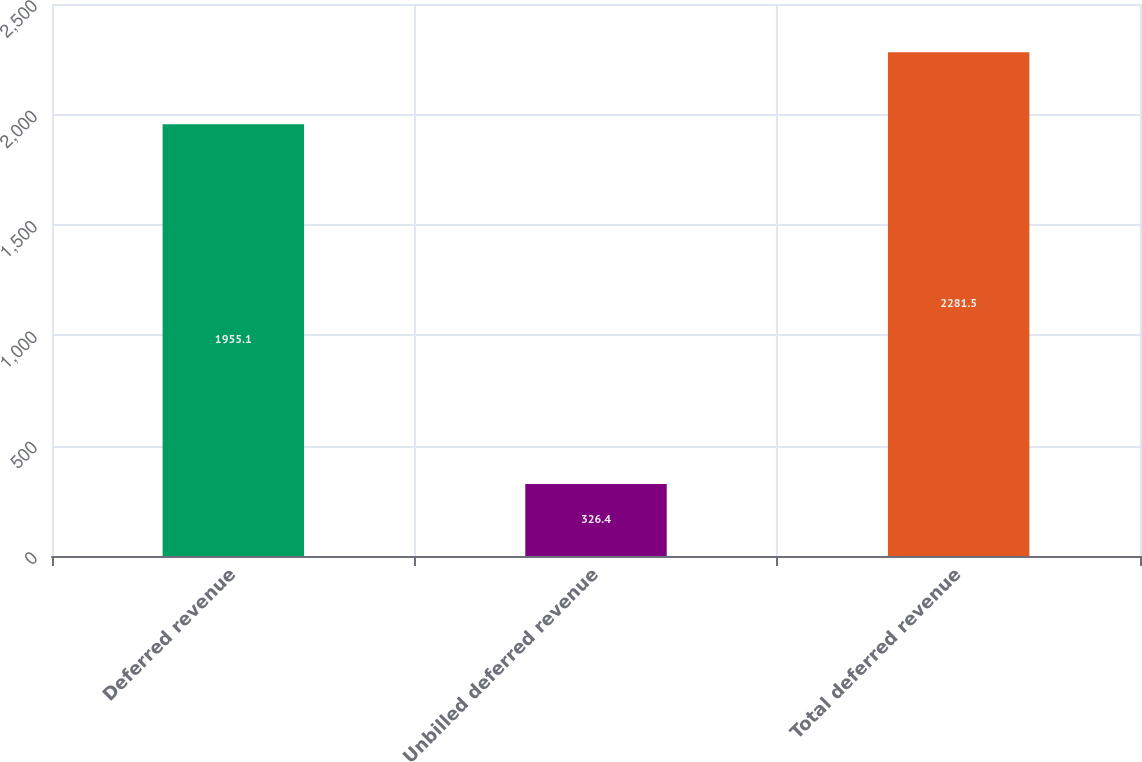Convert chart. <chart><loc_0><loc_0><loc_500><loc_500><bar_chart><fcel>Deferred revenue<fcel>Unbilled deferred revenue<fcel>Total deferred revenue<nl><fcel>1955.1<fcel>326.4<fcel>2281.5<nl></chart> 